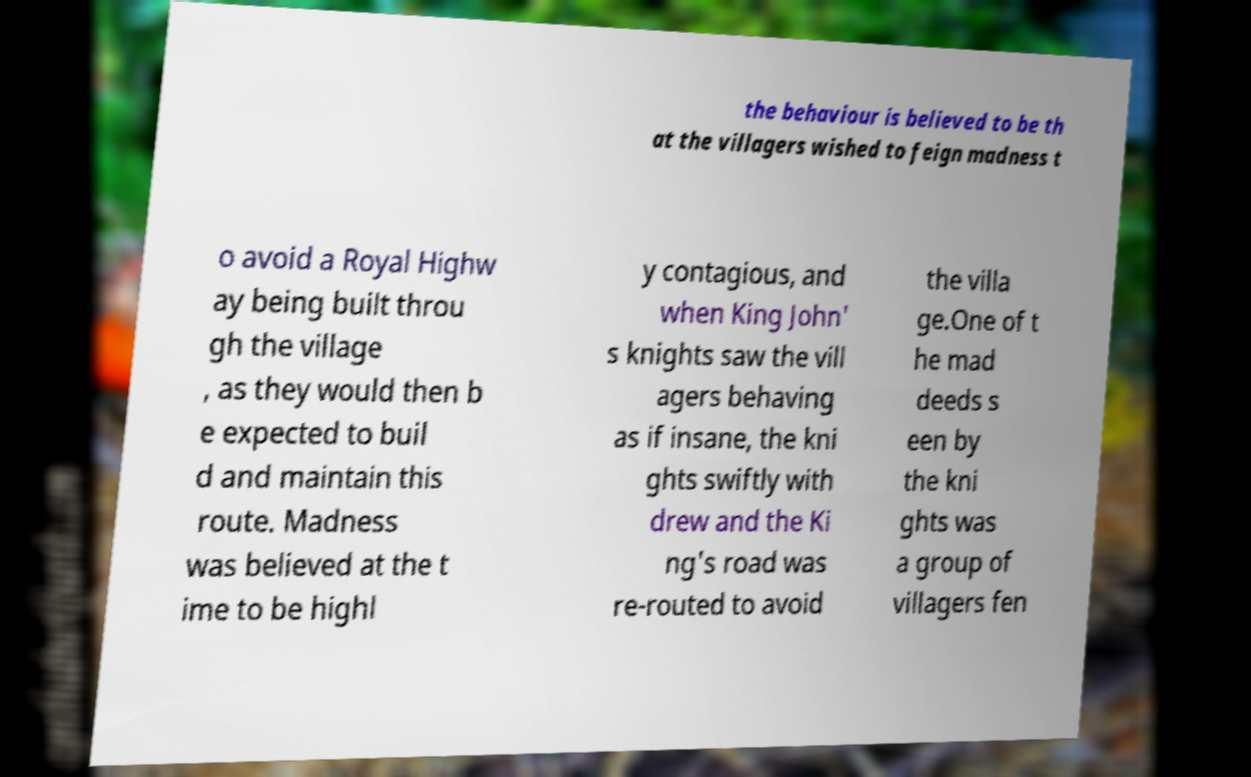What messages or text are displayed in this image? I need them in a readable, typed format. the behaviour is believed to be th at the villagers wished to feign madness t o avoid a Royal Highw ay being built throu gh the village , as they would then b e expected to buil d and maintain this route. Madness was believed at the t ime to be highl y contagious, and when King John' s knights saw the vill agers behaving as if insane, the kni ghts swiftly with drew and the Ki ng's road was re-routed to avoid the villa ge.One of t he mad deeds s een by the kni ghts was a group of villagers fen 